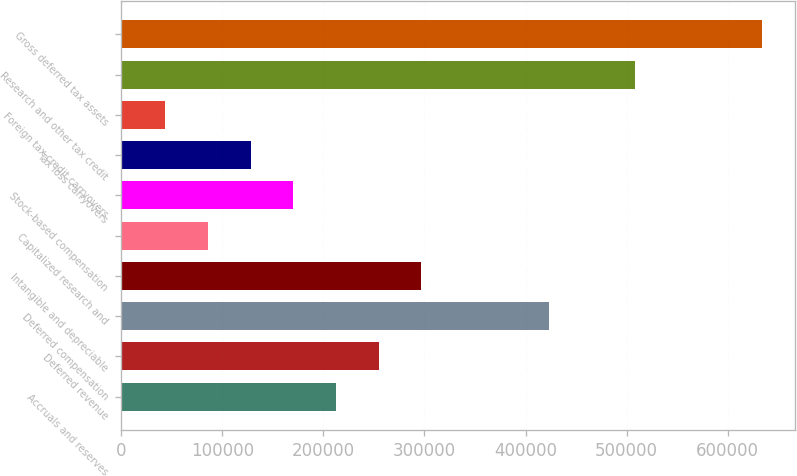<chart> <loc_0><loc_0><loc_500><loc_500><bar_chart><fcel>Accruals and reserves<fcel>Deferred revenue<fcel>Deferred compensation<fcel>Intangible and depreciable<fcel>Capitalized research and<fcel>Stock-based compensation<fcel>Tax loss carryovers<fcel>Foreign tax credit carryovers<fcel>Research and other tax credit<fcel>Gross deferred tax assets<nl><fcel>212370<fcel>254583<fcel>423439<fcel>296797<fcel>85727.8<fcel>170156<fcel>127942<fcel>43513.9<fcel>507867<fcel>634508<nl></chart> 